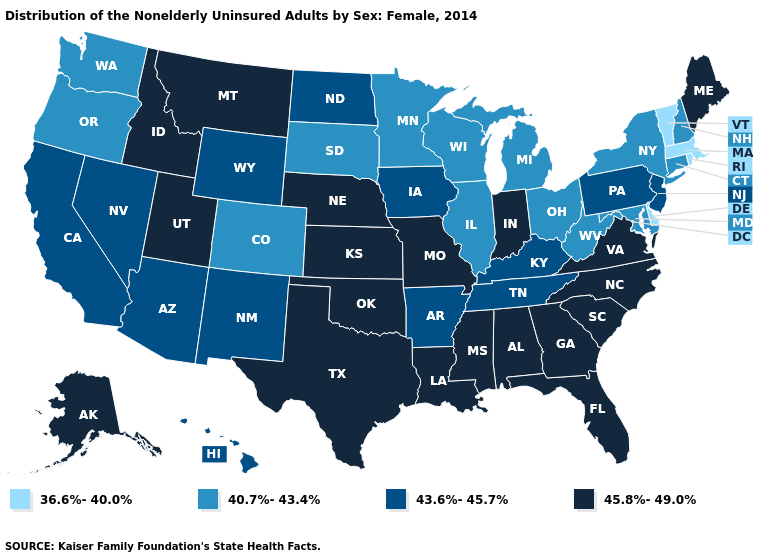What is the highest value in the USA?
Concise answer only. 45.8%-49.0%. What is the value of Illinois?
Quick response, please. 40.7%-43.4%. What is the lowest value in the MidWest?
Quick response, please. 40.7%-43.4%. Name the states that have a value in the range 36.6%-40.0%?
Answer briefly. Delaware, Massachusetts, Rhode Island, Vermont. Does Delaware have the lowest value in the USA?
Keep it brief. Yes. What is the highest value in states that border Tennessee?
Concise answer only. 45.8%-49.0%. What is the value of South Carolina?
Answer briefly. 45.8%-49.0%. What is the highest value in the USA?
Concise answer only. 45.8%-49.0%. Which states hav the highest value in the MidWest?
Quick response, please. Indiana, Kansas, Missouri, Nebraska. Name the states that have a value in the range 40.7%-43.4%?
Write a very short answer. Colorado, Connecticut, Illinois, Maryland, Michigan, Minnesota, New Hampshire, New York, Ohio, Oregon, South Dakota, Washington, West Virginia, Wisconsin. What is the value of Colorado?
Keep it brief. 40.7%-43.4%. Does Florida have the highest value in the USA?
Quick response, please. Yes. Among the states that border Louisiana , which have the lowest value?
Answer briefly. Arkansas. Name the states that have a value in the range 43.6%-45.7%?
Answer briefly. Arizona, Arkansas, California, Hawaii, Iowa, Kentucky, Nevada, New Jersey, New Mexico, North Dakota, Pennsylvania, Tennessee, Wyoming. What is the highest value in the MidWest ?
Write a very short answer. 45.8%-49.0%. 